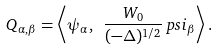<formula> <loc_0><loc_0><loc_500><loc_500>Q _ { \alpha , \beta } = \left < \psi _ { \alpha } , \ { \frac { W _ { 0 } } { ( - \Delta ) ^ { 1 / 2 } } } \, p s i _ { \beta } \right > .</formula> 